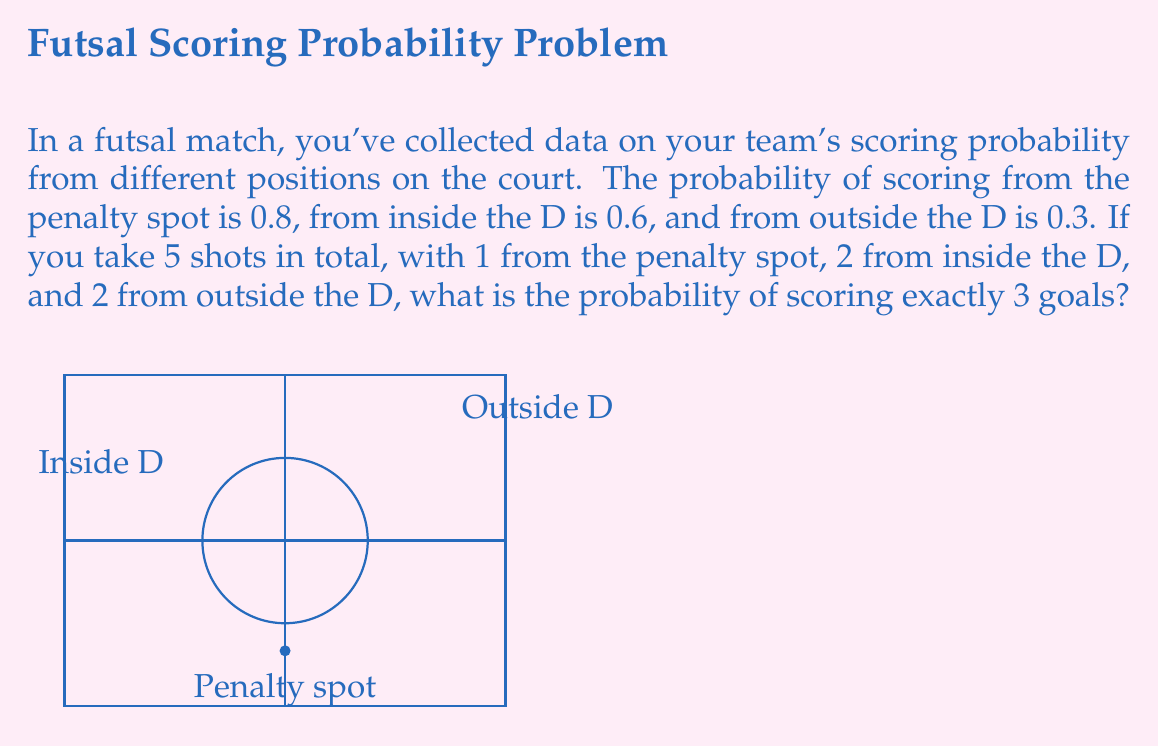Give your solution to this math problem. Let's approach this step-by-step using the binomial probability formula and the multiplication rule of probability:

1) We need to consider all possible ways to score exactly 3 goals out of 5 shots. The possible combinations are:
   - Score from penalty spot (P) and both inside D shots (I), miss both outside D shots (O)
   - Score from P, one I, and one O
   - Score from P and both O, miss both I
   - Miss P, score both I and one O
   - Miss P, score one I and both O

2) Let's calculate the probability for each scenario:

   a) P(P) * P(I) * P(I) * (1-P(O)) * (1-P(O))
      = 0.8 * 0.6 * 0.6 * 0.7 * 0.7 = 0.14112

   b) P(P) * P(I) * (1-P(I)) * P(O) * (1-P(O)) * 2 (because we can choose either of the two I shots)
      = 0.8 * 0.6 * 0.4 * 0.3 * 0.7 * 2 = 0.08064

   c) P(P) * (1-P(I)) * (1-P(I)) * P(O) * P(O)
      = 0.8 * 0.4 * 0.4 * 0.3 * 0.3 = 0.00576

   d) (1-P(P)) * P(I) * P(I) * P(O) * (1-P(O)) * 2 (because we can choose either of the two O shots)
      = 0.2 * 0.6 * 0.6 * 0.3 * 0.7 * 2 = 0.03024

   e) (1-P(P)) * P(I) * (1-P(I)) * P(O) * P(O)
      = 0.2 * 0.6 * 0.4 * 0.3 * 0.3 = 0.00432

3) The total probability is the sum of all these scenarios:
   
   $$P(\text{exactly 3 goals}) = 0.14112 + 0.08064 + 0.00576 + 0.03024 + 0.00432 = 0.26208$$
Answer: 0.26208 